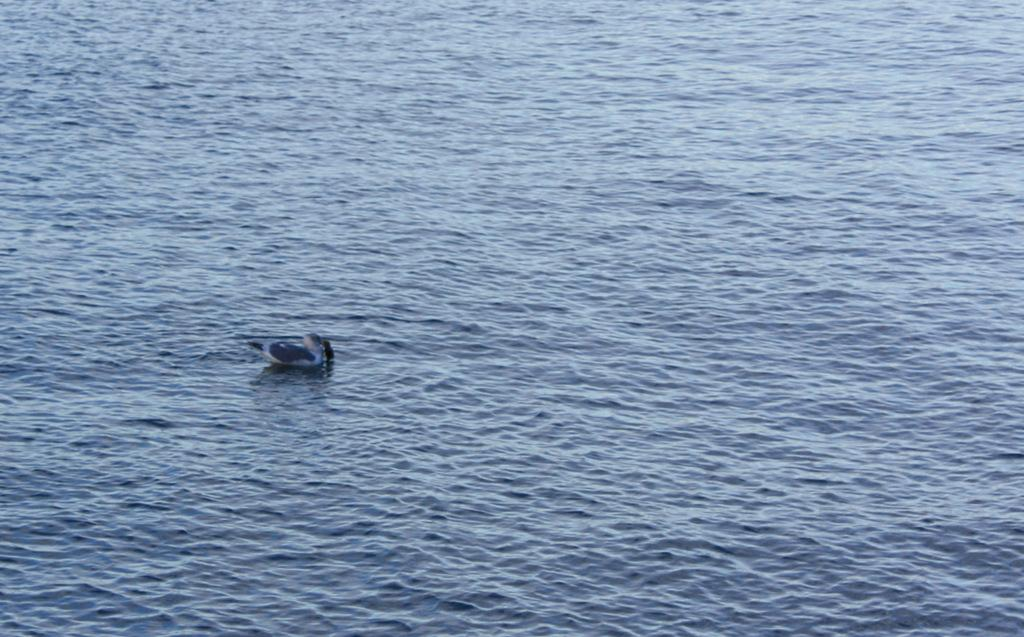What animal is present in the image? There is a duck in the image. Where is the duck located? The duck is on the water. What disease is affecting the duck in the image? There is no indication of any disease affecting the duck in the image. 